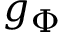Convert formula to latex. <formula><loc_0><loc_0><loc_500><loc_500>g _ { \Phi }</formula> 